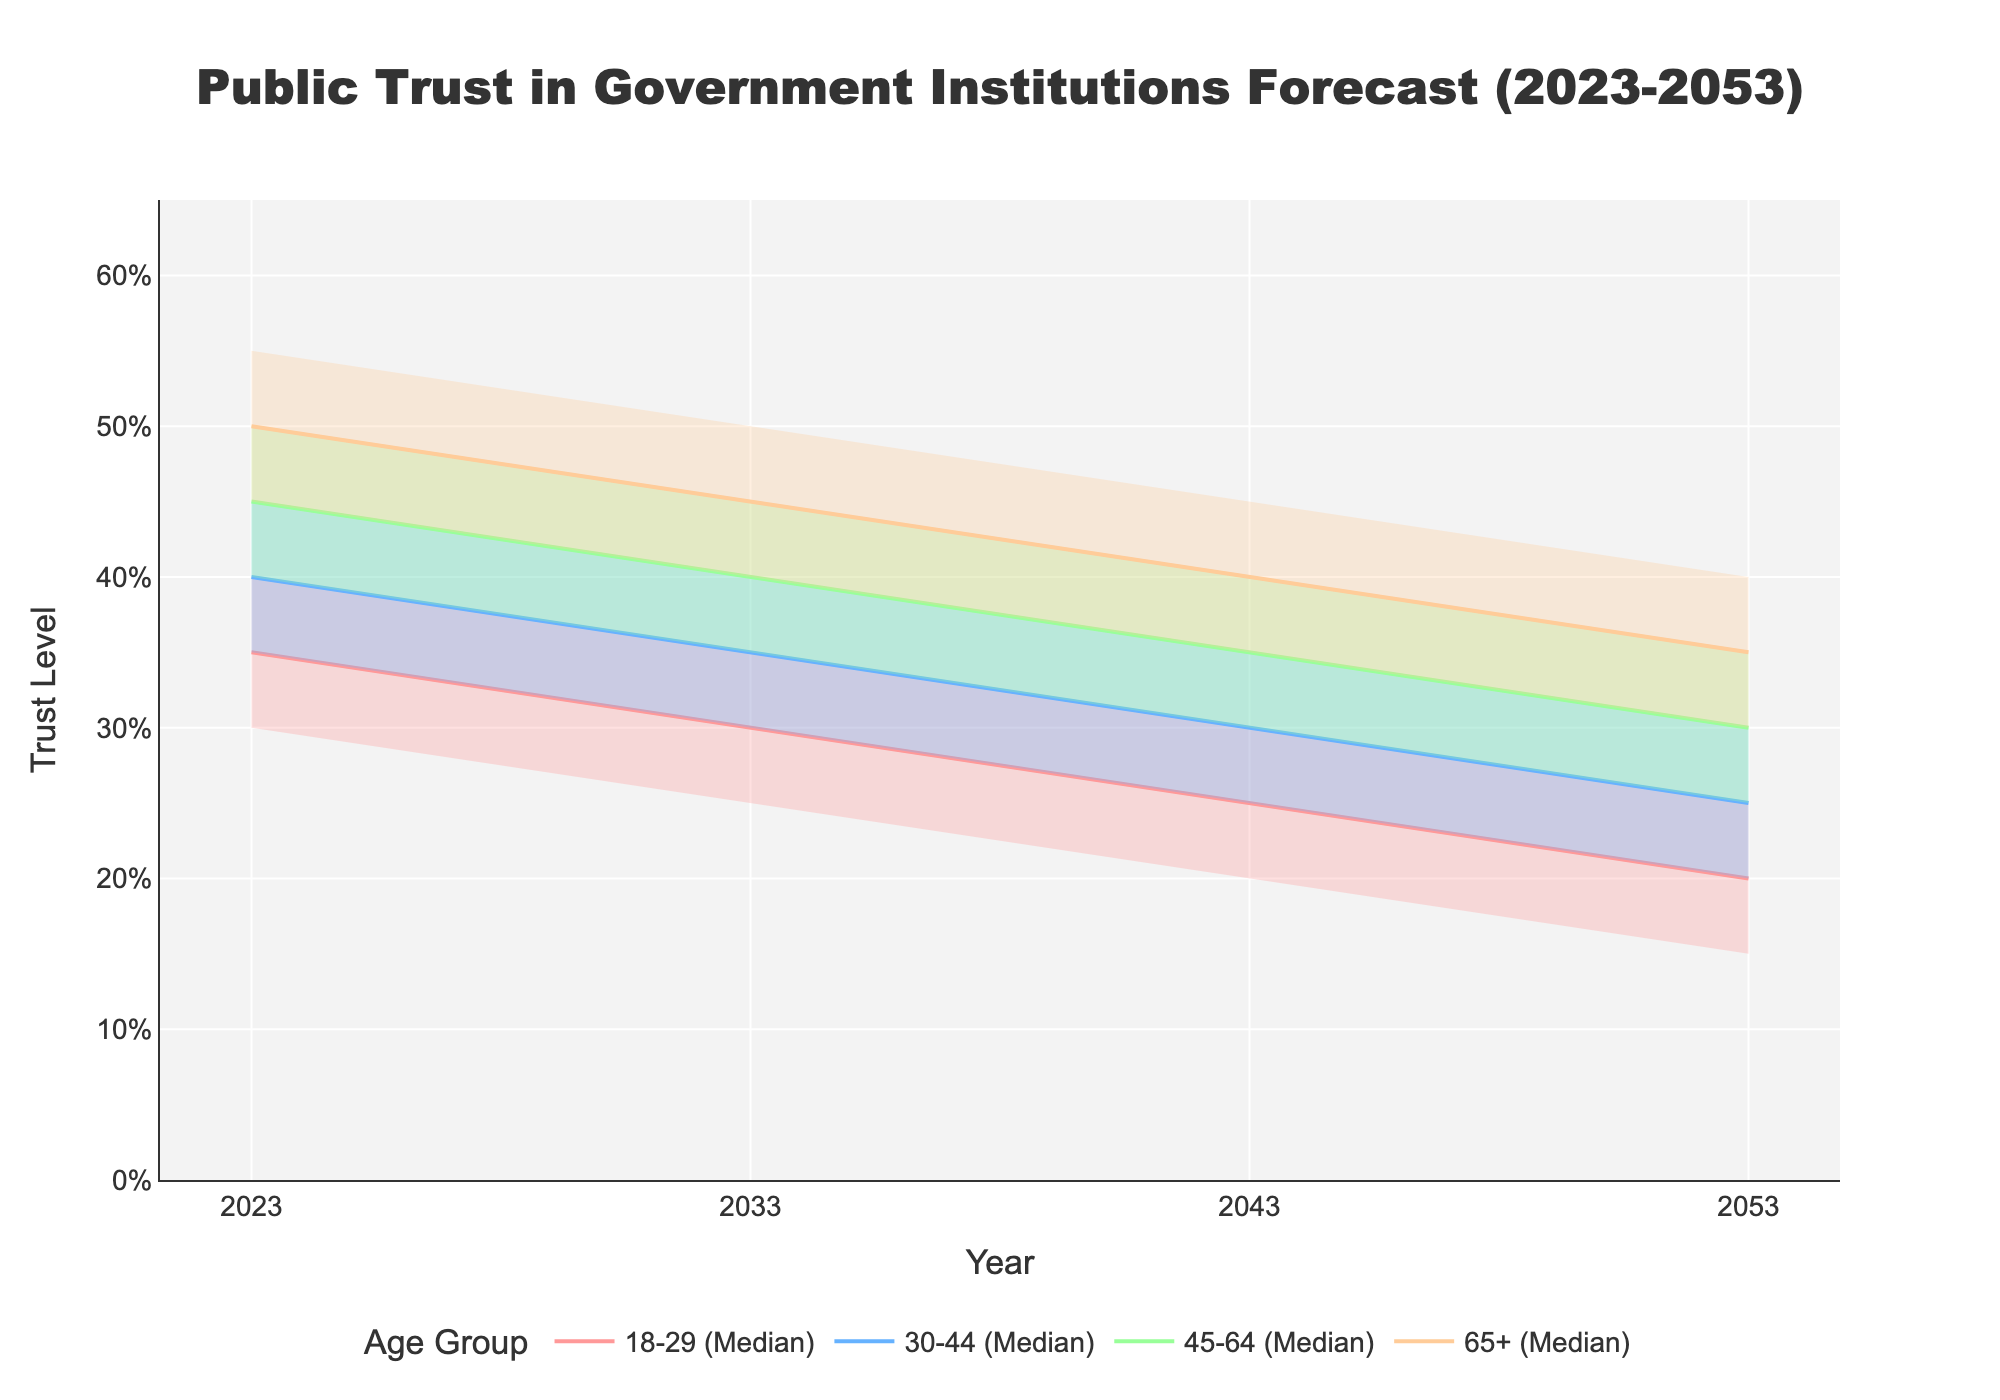What's the title of the figure? The title is located at the top of the figure. By observing the top center portion, we can read "Public Trust in Government Institutions Forecast (2023-2053)".
Answer: Public Trust in Government Institutions Forecast (2023-2053) How many age groups are represented in the chart? By checking the legend or the labels associated with the data, we can see that there are four age groups labeled: 18-29, 30-44, 45-64, and 65+.
Answer: 4 What is the median trust level for the 18-29 age group in the year 2043? Locate the data point for the median of the 18-29 age group at the year 2043. The median value is marked on the y-axis corresponding to the plotted line for that group.
Answer: 25% How does the median trust level in 2023 compare between age groups 18-29 and 65+? Reference the median values for both age groups in the year 2023. The 18-29 group has a median trust level of 35%, while the 65+ group has a median trust level of 50%. Comparing these two values, 65+ has a higher trust level.
Answer: 65+ has a higher trust level Which age group shows the largest decrease in median trust level from 2023 to 2053? Track the median trust levels for each age group from 2023 to 2053. Calculate the difference: 
- 18-29: 35% - 20% = 15%
- 30-44: 40% - 25% = 15%
- 45-64: 45% - 30% = 15%
- 65+: 50% - 35% = 15%
Here, each age group shows an equal decrease of 15%.
Answer: All age groups (equal decrease) What is the range of trust levels for the 30-44 age group in the year 2033? Find the upper and lower estimates for the 30-44 age group in 2033. The upper estimate is 45%, and the lower estimate is 25%. The range calculation is 45% - 25% = 20%.
Answer: 20% Which age group has the highest upper quartile in the year 2023? Compare the upper quartile values for all age groups in 2023. The values are 40% (18-29), 45% (30-44), 50% (45-64), and 55% (65+). The highest upper quartile in 2023 is for age group 65+.
Answer: 65+ What does the shaded area represent for each age group? The shaded area between the upper and lower quartiles for each age group represents the interquartile range (the middle 50% of the data). This area gives an idea about the distribution of trust levels over the forecast period.
Answer: Interquartile range (middle 50%) In the year 2053, which age group has the lowest lower estimate of trust level? Look for the lowest lower estimate value among all age groups in 2053. The values are 10% (18-29), 15% (30-44), 20% (45-64), and 25% (65+). The lowest is for the 18-29 age group.
Answer: 18-29 